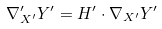Convert formula to latex. <formula><loc_0><loc_0><loc_500><loc_500>\nabla ^ { \prime } _ { X ^ { \prime } } Y ^ { \prime } = H ^ { \prime } \cdot \nabla _ { X ^ { \prime } } Y ^ { \prime }</formula> 